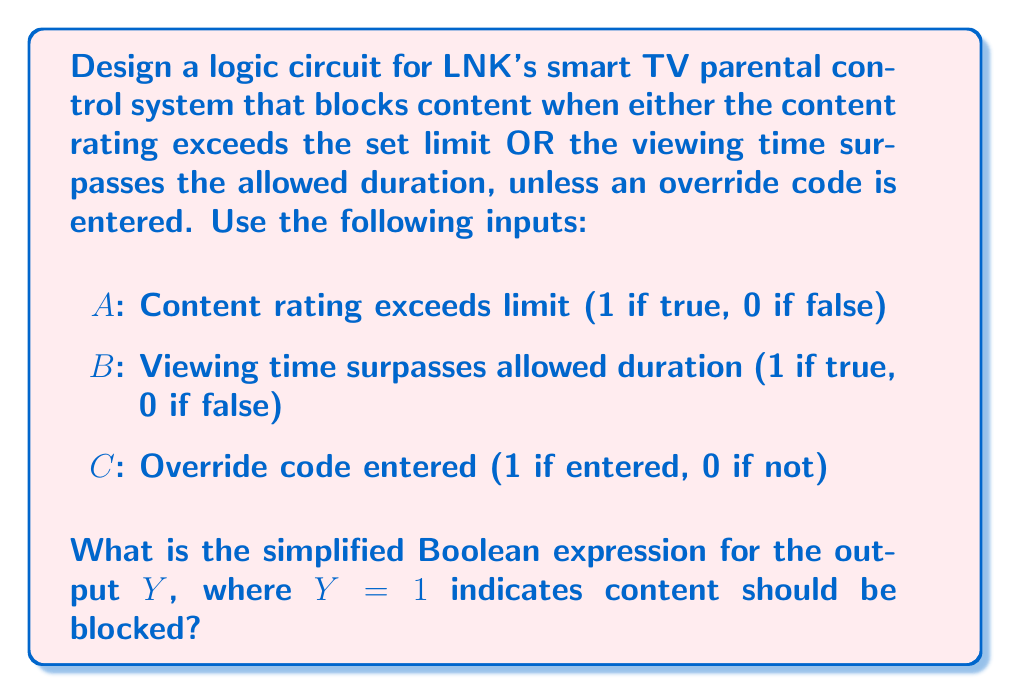Solve this math problem. Let's approach this step-by-step:

1) First, we need to block content when either A OR B is true, which can be expressed as:
   $$(A + B)$$

2) However, the override code (C) should prevent blocking when entered. This means we want the final output to be 0 when C is 1, regardless of A and B. We can achieve this with an AND operation:
   $$(A + B) \cdot \overline{C}$$

3) This expression can be read as: "Block content if (A OR B) is true AND C is false."

4) We can simplify this using Boolean algebra laws:
   $$(A + B) \cdot \overline{C} = A\overline{C} + B\overline{C}$$

This final expression, $A\overline{C} + B\overline{C}$, is the simplified Boolean expression for the parental control system.

To verify:
- If A=1 (rating exceeded) and C=0 (no override), Y=1 (blocked)
- If B=1 (time exceeded) and C=0 (no override), Y=1 (blocked)
- If C=1 (override entered), Y=0 (not blocked) regardless of A and B

This logic ensures that LNK's smart TV provides effective parental controls while allowing for override when necessary.
Answer: $$Y = A\overline{C} + B\overline{C}$$ 